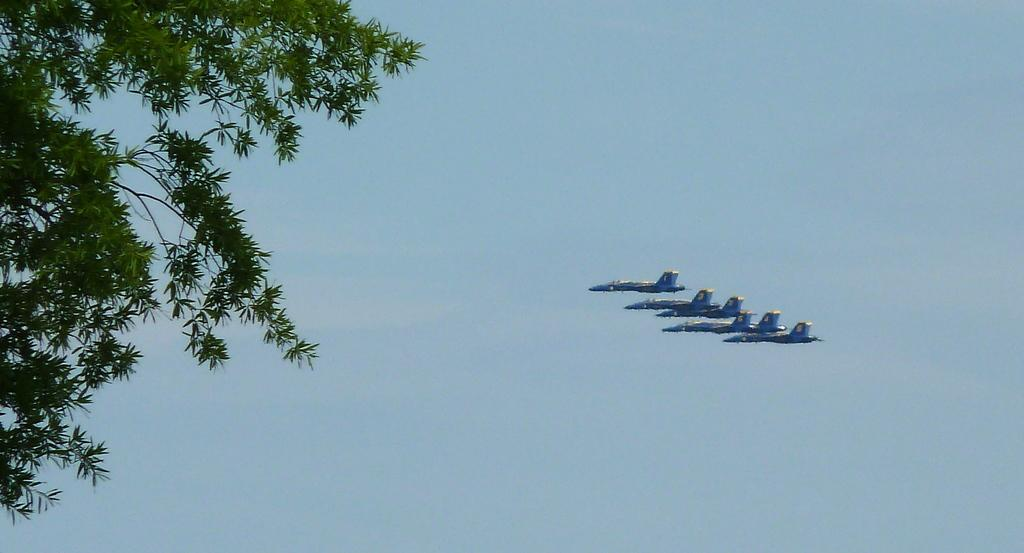What is happening in the sky in the image? There are five jets flying in the sky in the image. What can be seen on the left side of the image? There is a tree on the left side of the image. What type of popcorn is being served at the design conference happening near the tree? There is no popcorn or design conference present in the image; it only features five jets flying in the sky and a tree on the left side. 